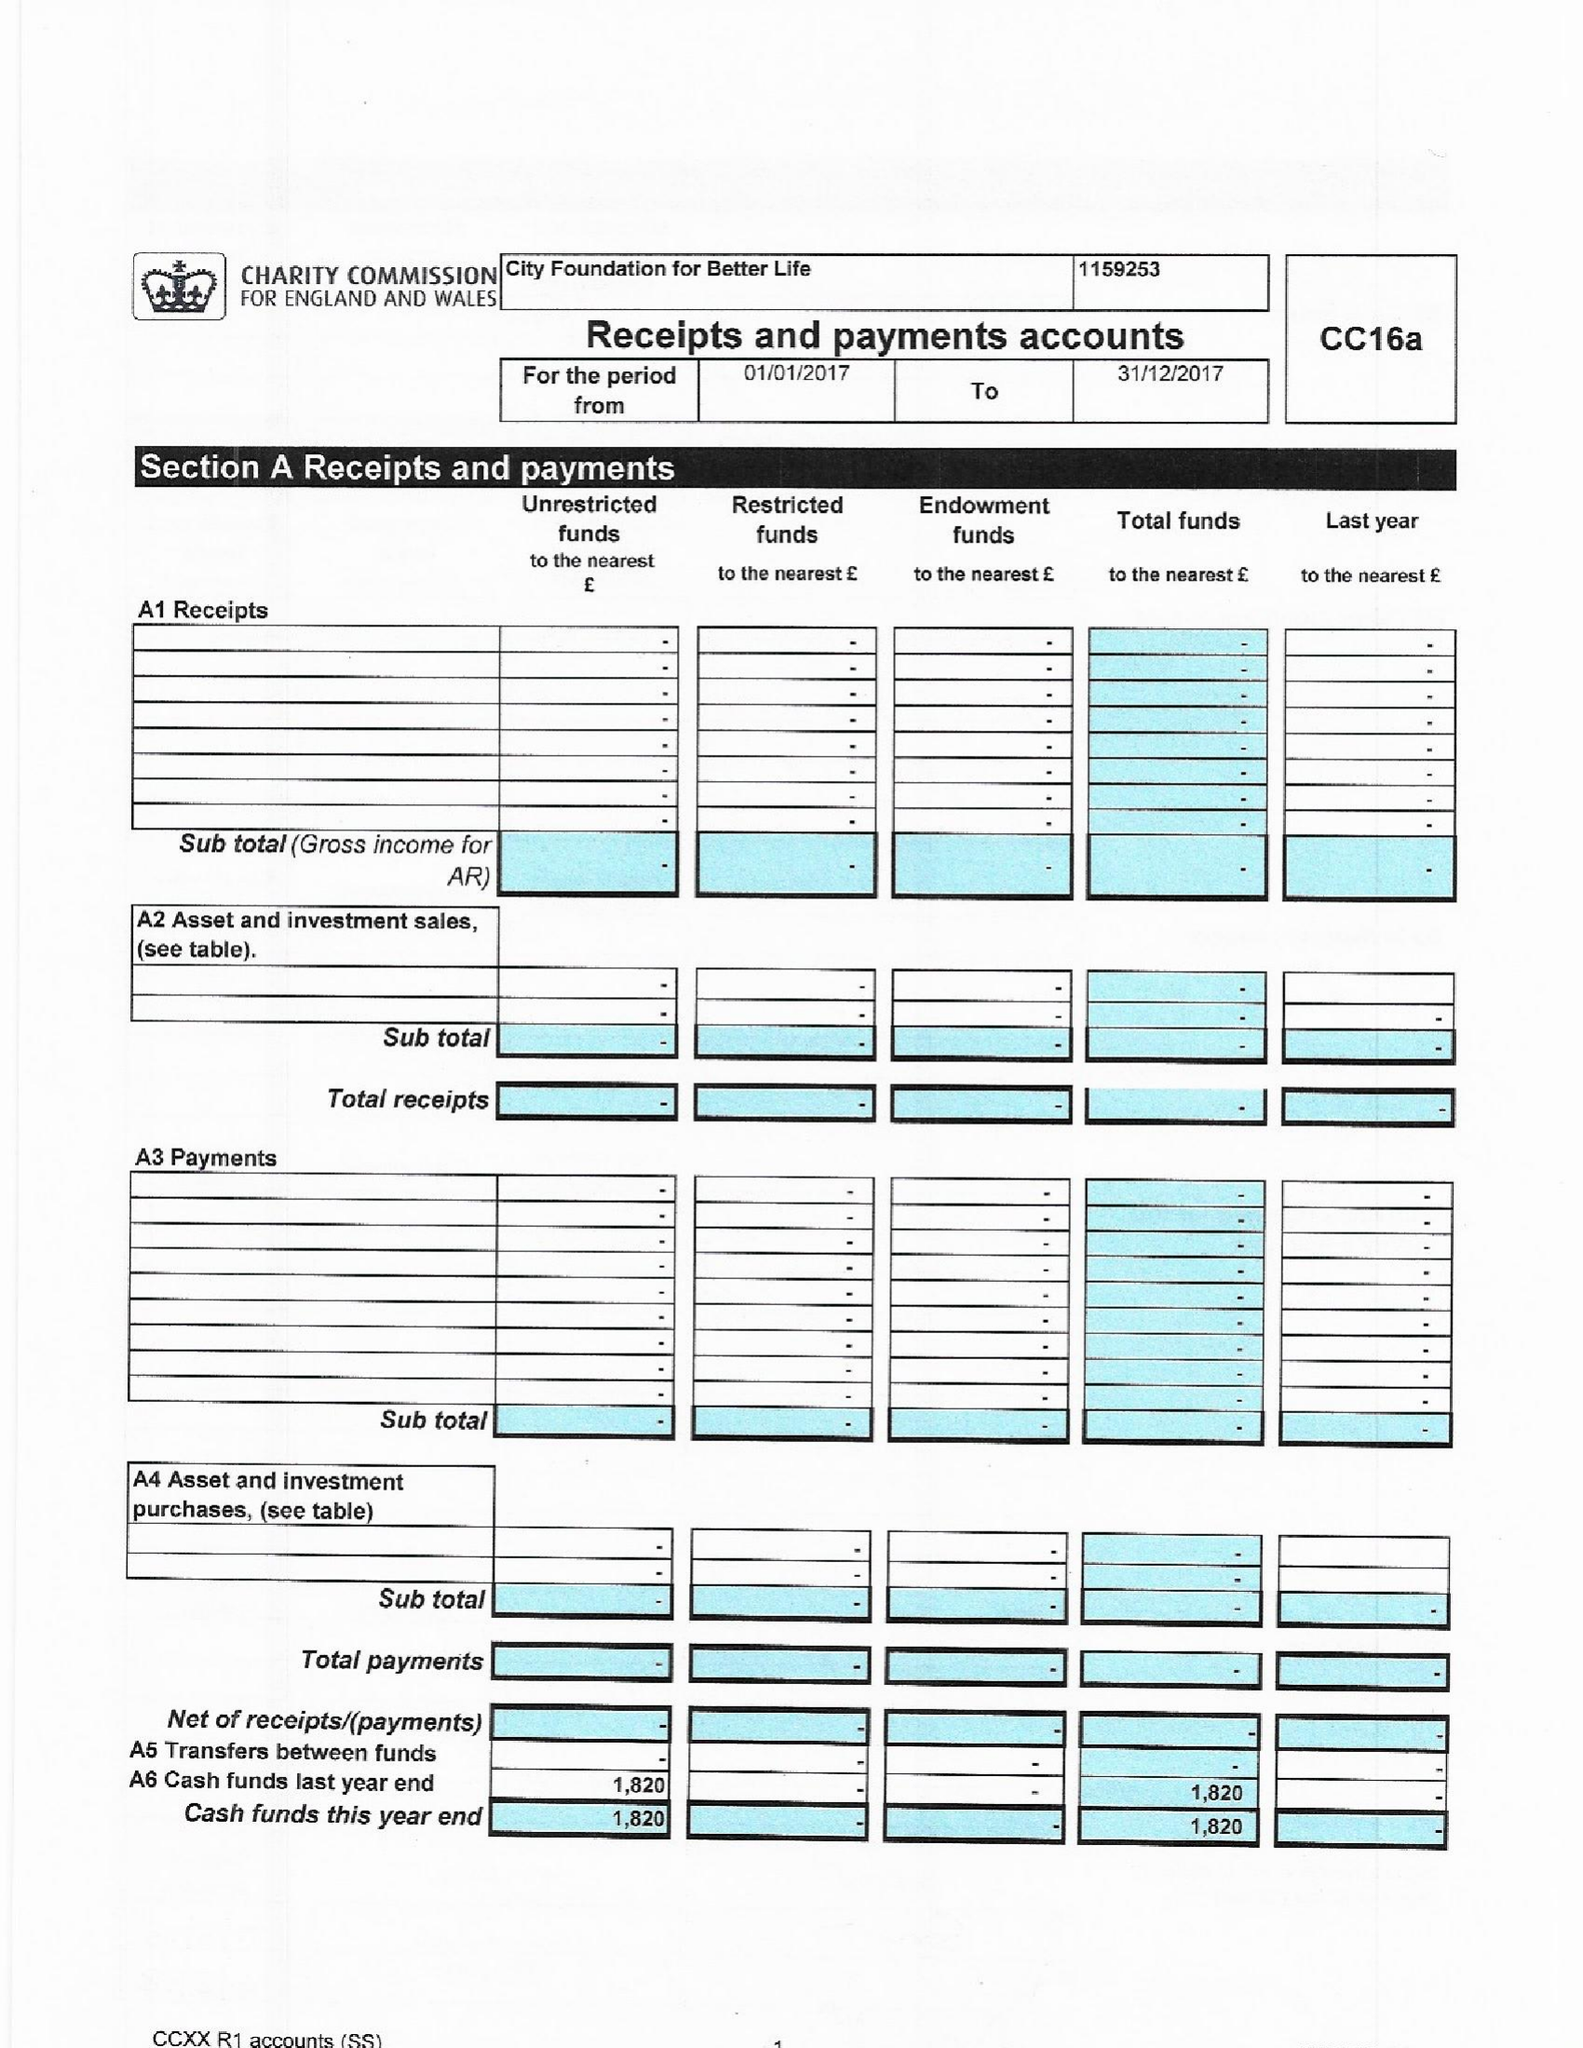What is the value for the income_annually_in_british_pounds?
Answer the question using a single word or phrase. None 